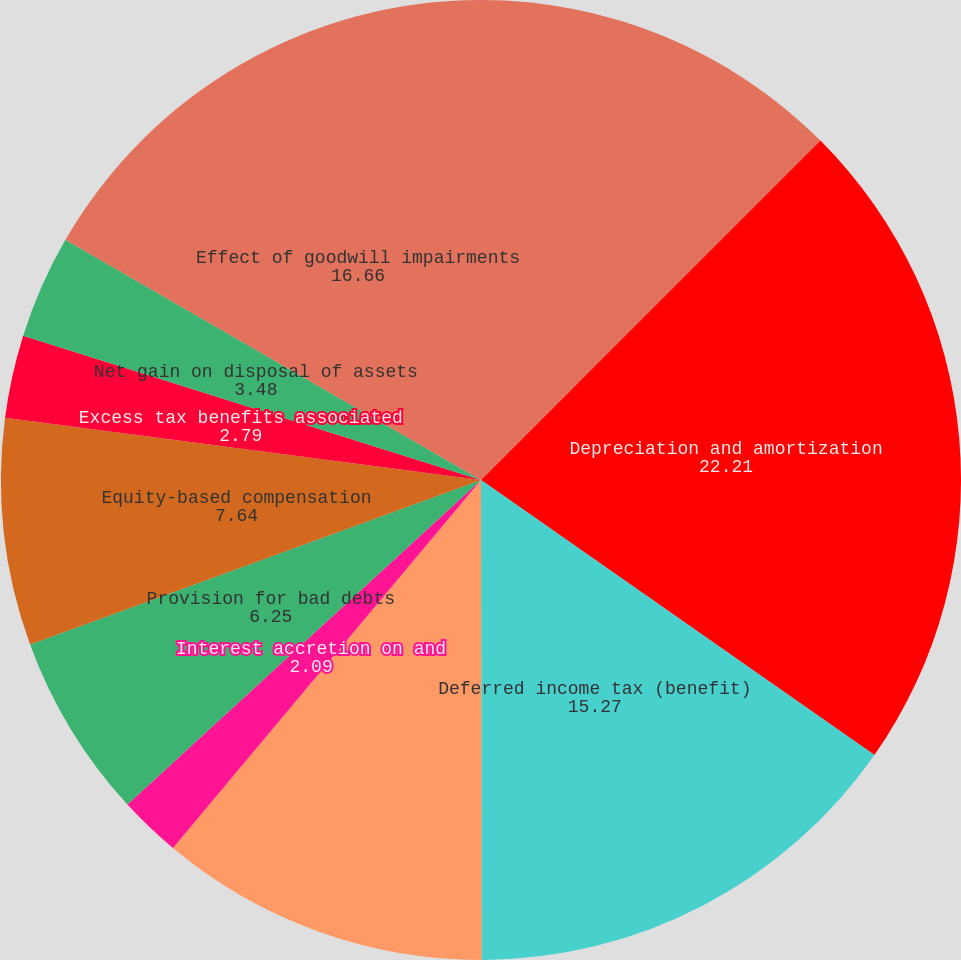<chart> <loc_0><loc_0><loc_500><loc_500><pie_chart><fcel>Consolidated net income<fcel>Depreciation and amortization<fcel>Deferred income tax (benefit)<fcel>Interest accretion on landfill<fcel>Interest accretion on and<fcel>Provision for bad debts<fcel>Equity-based compensation<fcel>Excess tax benefits associated<fcel>Net gain on disposal of assets<fcel>Effect of goodwill impairments<nl><fcel>12.5%<fcel>22.21%<fcel>15.27%<fcel>11.11%<fcel>2.09%<fcel>6.25%<fcel>7.64%<fcel>2.79%<fcel>3.48%<fcel>16.66%<nl></chart> 